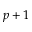Convert formula to latex. <formula><loc_0><loc_0><loc_500><loc_500>p + 1</formula> 